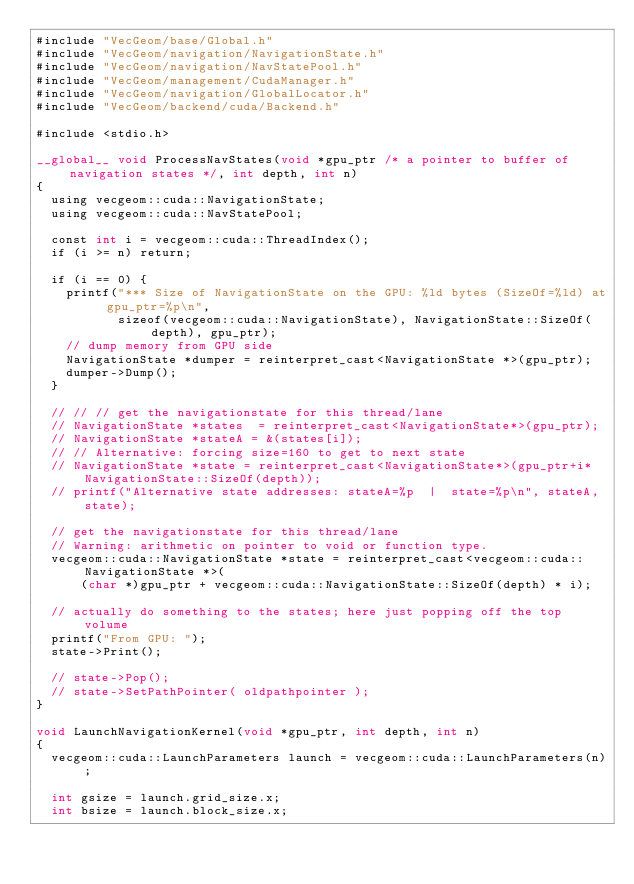Convert code to text. <code><loc_0><loc_0><loc_500><loc_500><_Cuda_>#include "VecGeom/base/Global.h"
#include "VecGeom/navigation/NavigationState.h"
#include "VecGeom/navigation/NavStatePool.h"
#include "VecGeom/management/CudaManager.h"
#include "VecGeom/navigation/GlobalLocator.h"
#include "VecGeom/backend/cuda/Backend.h"

#include <stdio.h>

__global__ void ProcessNavStates(void *gpu_ptr /* a pointer to buffer of navigation states */, int depth, int n)
{
  using vecgeom::cuda::NavigationState;
  using vecgeom::cuda::NavStatePool;

  const int i = vecgeom::cuda::ThreadIndex();
  if (i >= n) return;

  if (i == 0) {
    printf("*** Size of NavigationState on the GPU: %ld bytes (SizeOf=%ld) at gpu_ptr=%p\n",
           sizeof(vecgeom::cuda::NavigationState), NavigationState::SizeOf(depth), gpu_ptr);
    // dump memory from GPU side
    NavigationState *dumper = reinterpret_cast<NavigationState *>(gpu_ptr);
    dumper->Dump();
  }

  // // // get the navigationstate for this thread/lane
  // NavigationState *states  = reinterpret_cast<NavigationState*>(gpu_ptr);
  // NavigationState *stateA = &(states[i]);
  // // Alternative: forcing size=160 to get to next state
  // NavigationState *state = reinterpret_cast<NavigationState*>(gpu_ptr+i*NavigationState::SizeOf(depth));
  // printf("Alternative state addresses: stateA=%p  |  state=%p\n", stateA, state);

  // get the navigationstate for this thread/lane
  // Warning: arithmetic on pointer to void or function type.
  vecgeom::cuda::NavigationState *state = reinterpret_cast<vecgeom::cuda::NavigationState *>(
      (char *)gpu_ptr + vecgeom::cuda::NavigationState::SizeOf(depth) * i);

  // actually do something to the states; here just popping off the top volume
  printf("From GPU: ");
  state->Print();

  // state->Pop();
  // state->SetPathPointer( oldpathpointer );
}

void LaunchNavigationKernel(void *gpu_ptr, int depth, int n)
{
  vecgeom::cuda::LaunchParameters launch = vecgeom::cuda::LaunchParameters(n);

  int gsize = launch.grid_size.x;
  int bsize = launch.block_size.x;</code> 